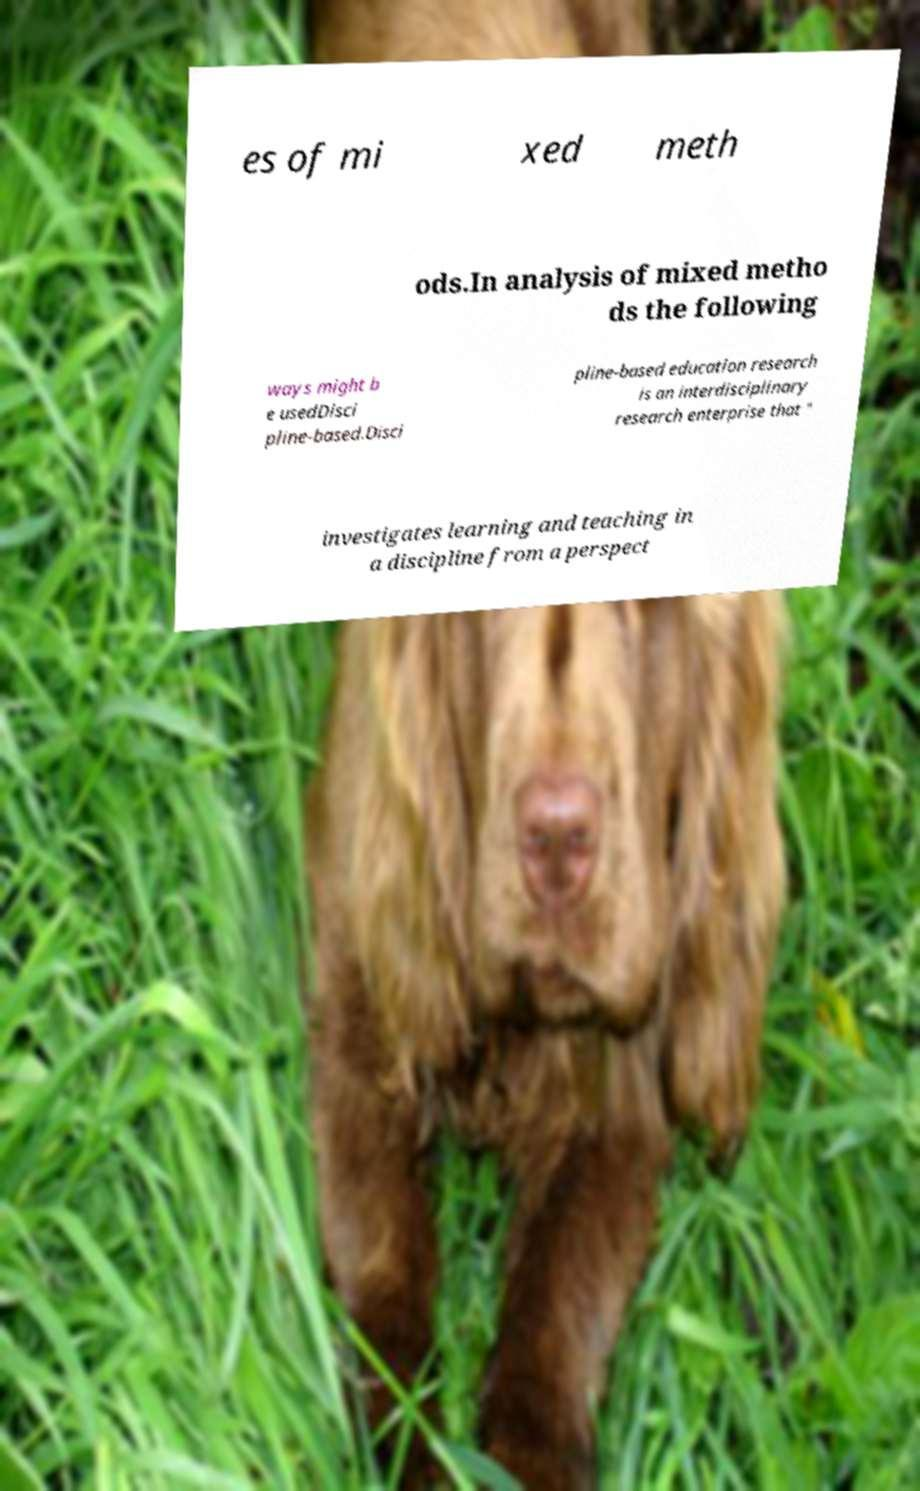Could you assist in decoding the text presented in this image and type it out clearly? es of mi xed meth ods.In analysis of mixed metho ds the following ways might b e usedDisci pline-based.Disci pline-based education research is an interdisciplinary research enterprise that " investigates learning and teaching in a discipline from a perspect 